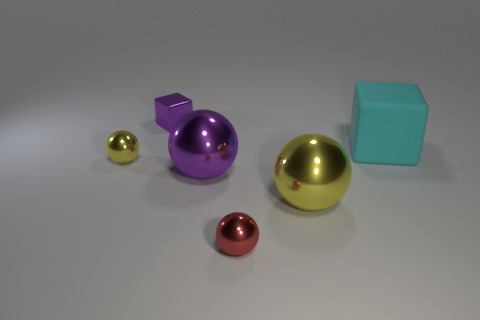What time of day does the lighting in this image suggest? The image doesn't provide clear environmental context for time of day, but the lighting is soft and diffused, which is often associated with either morning or late afternoon in an indoor setting. 